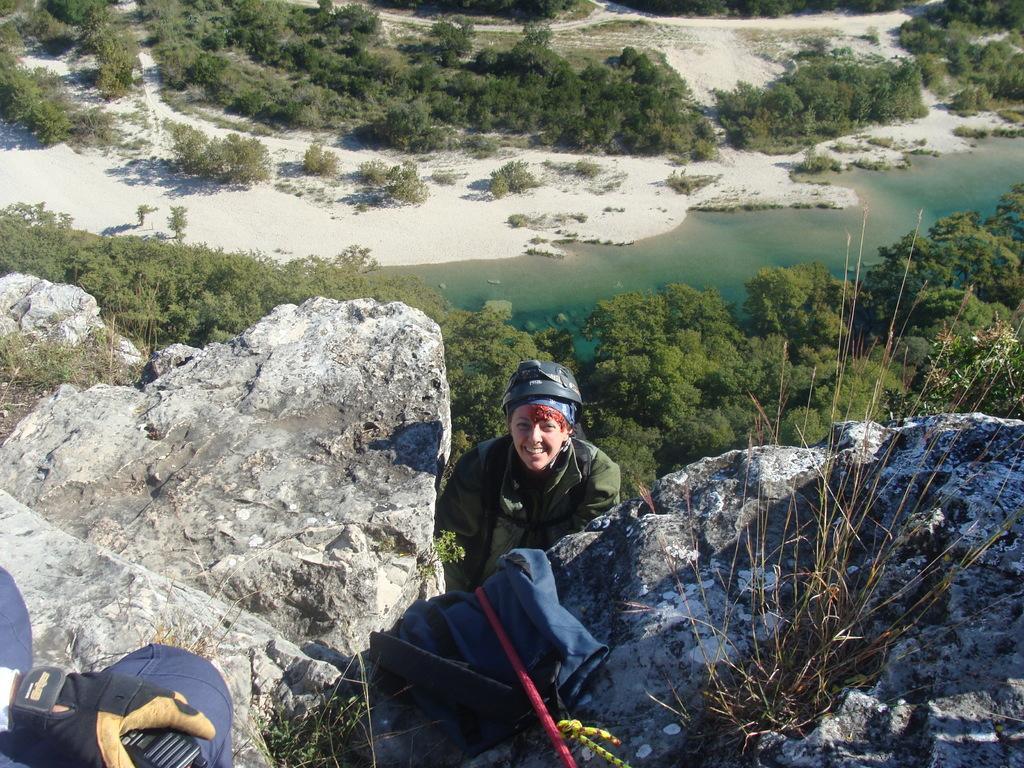In one or two sentences, can you explain what this image depicts? It is image in the center there is a person smiling. In the front there is a stick and there is a person and there is a dry plant. In the background there are trees and there is water. 